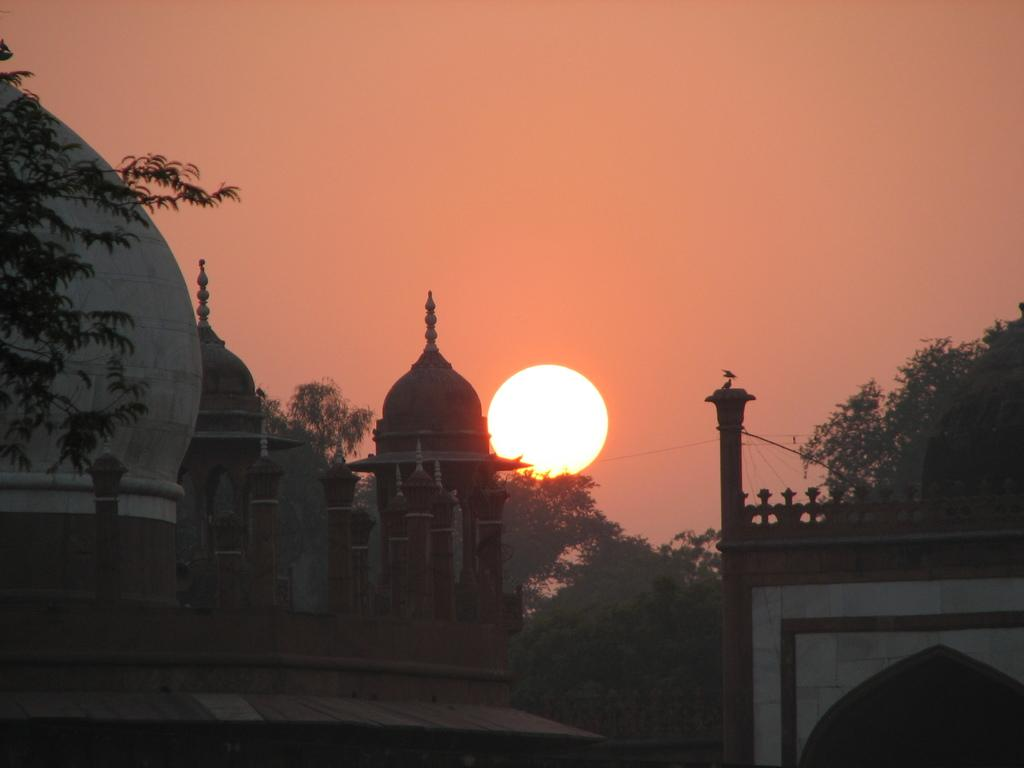What type of structures are present in the image? There are tomb buildings in the image. What other elements can be seen in the image besides the tomb buildings? There are trees in the image. What is the condition of the sky in the image? The sun is visible in the sky. How many legs does the dinosaur have in the image? There are no dinosaurs present in the image, so it is not possible to determine the number of legs they might have. 